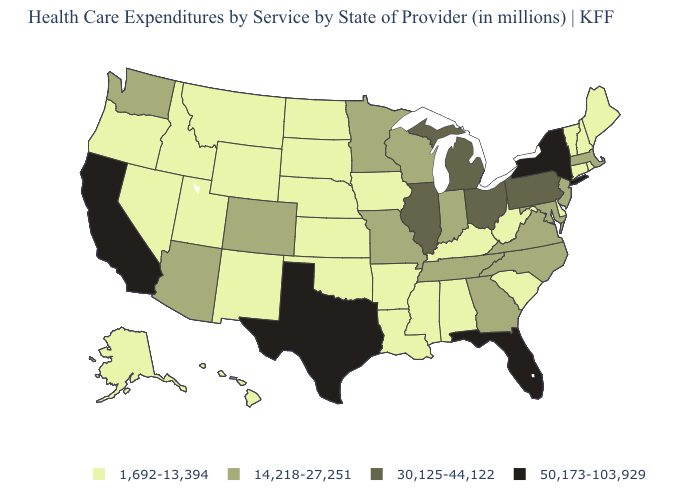What is the highest value in states that border Louisiana?
Quick response, please. 50,173-103,929. Does the first symbol in the legend represent the smallest category?
Give a very brief answer. Yes. Which states have the lowest value in the USA?
Keep it brief. Alabama, Alaska, Arkansas, Connecticut, Delaware, Hawaii, Idaho, Iowa, Kansas, Kentucky, Louisiana, Maine, Mississippi, Montana, Nebraska, Nevada, New Hampshire, New Mexico, North Dakota, Oklahoma, Oregon, Rhode Island, South Carolina, South Dakota, Utah, Vermont, West Virginia, Wyoming. Is the legend a continuous bar?
Concise answer only. No. Which states hav the highest value in the Northeast?
Keep it brief. New York. Does the map have missing data?
Be succinct. No. What is the value of Oklahoma?
Short answer required. 1,692-13,394. Does New York have the highest value in the USA?
Short answer required. Yes. Which states hav the highest value in the South?
Keep it brief. Florida, Texas. What is the lowest value in the West?
Be succinct. 1,692-13,394. What is the value of Alaska?
Concise answer only. 1,692-13,394. What is the value of Oklahoma?
Answer briefly. 1,692-13,394. What is the lowest value in the MidWest?
Be succinct. 1,692-13,394. Which states have the highest value in the USA?
Be succinct. California, Florida, New York, Texas. 